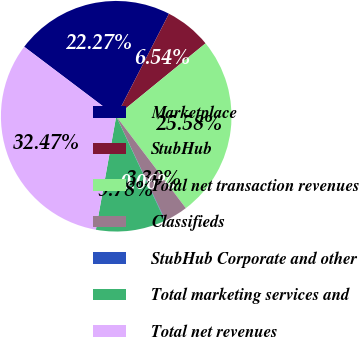Convert chart. <chart><loc_0><loc_0><loc_500><loc_500><pie_chart><fcel>Marketplace<fcel>StubHub<fcel>Total net transaction revenues<fcel>Classifieds<fcel>StubHub Corporate and other<fcel>Total marketing services and<fcel>Total net revenues<nl><fcel>22.27%<fcel>6.54%<fcel>25.58%<fcel>3.3%<fcel>0.06%<fcel>9.78%<fcel>32.47%<nl></chart> 